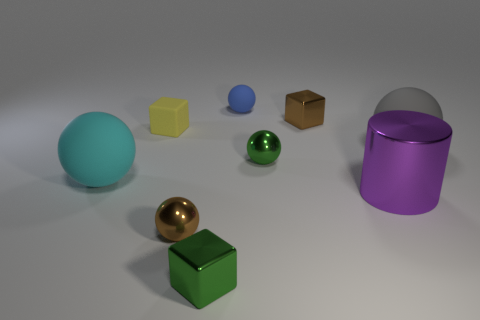Subtract 2 balls. How many balls are left? 3 Subtract all tiny brown spheres. How many spheres are left? 4 Subtract all purple balls. Subtract all red cylinders. How many balls are left? 5 Add 1 tiny brown metallic blocks. How many objects exist? 10 Subtract all cubes. How many objects are left? 6 Subtract 0 cyan blocks. How many objects are left? 9 Subtract all gray rubber spheres. Subtract all green shiny cubes. How many objects are left? 7 Add 1 large purple objects. How many large purple objects are left? 2 Add 8 yellow things. How many yellow things exist? 9 